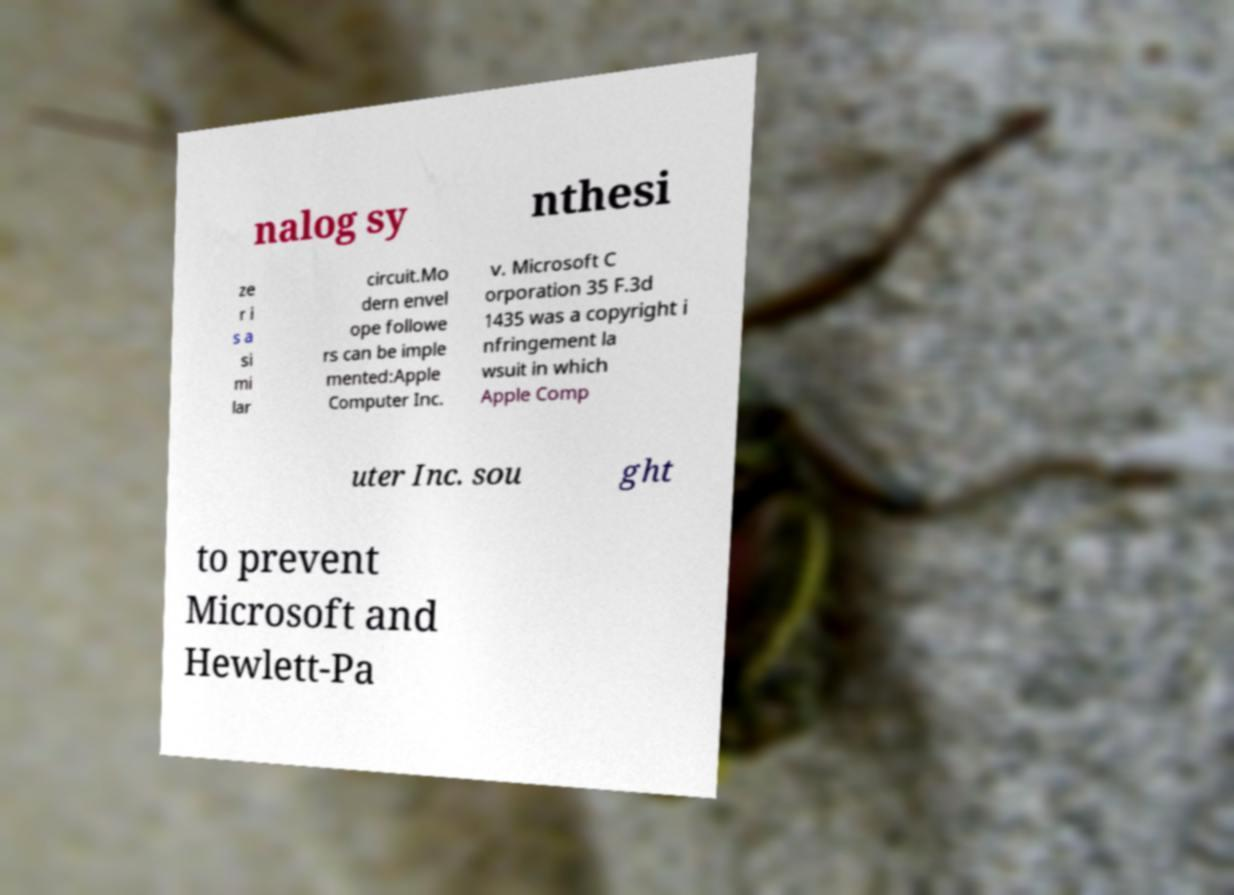What messages or text are displayed in this image? I need them in a readable, typed format. nalog sy nthesi ze r i s a si mi lar circuit.Mo dern envel ope followe rs can be imple mented:Apple Computer Inc. v. Microsoft C orporation 35 F.3d 1435 was a copyright i nfringement la wsuit in which Apple Comp uter Inc. sou ght to prevent Microsoft and Hewlett-Pa 